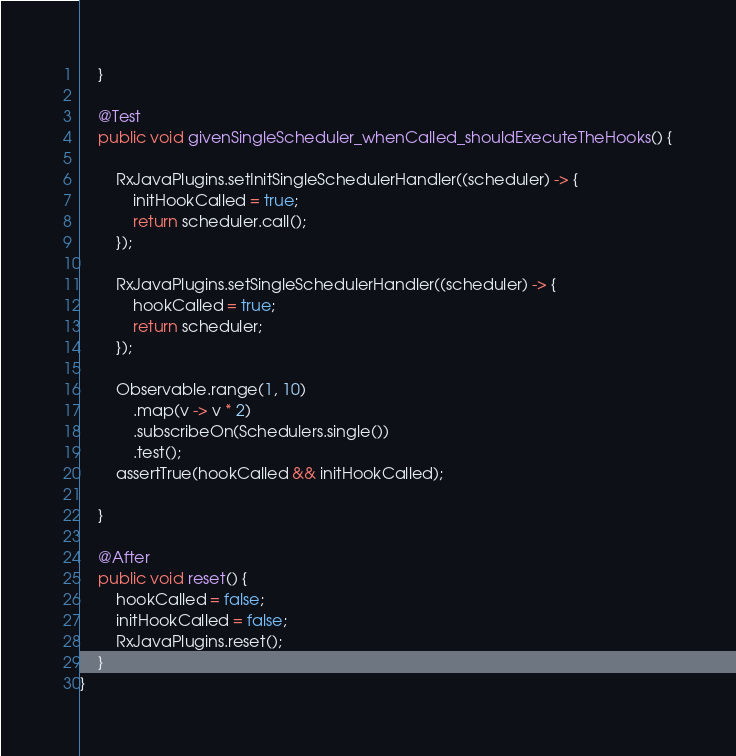<code> <loc_0><loc_0><loc_500><loc_500><_Java_>    }

    @Test
    public void givenSingleScheduler_whenCalled_shouldExecuteTheHooks() {

        RxJavaPlugins.setInitSingleSchedulerHandler((scheduler) -> {
            initHookCalled = true;
            return scheduler.call();
        });

        RxJavaPlugins.setSingleSchedulerHandler((scheduler) -> {
            hookCalled = true;
            return scheduler;
        });

        Observable.range(1, 10)
            .map(v -> v * 2)
            .subscribeOn(Schedulers.single())
            .test();
        assertTrue(hookCalled && initHookCalled);

    }
    
    @After
    public void reset() {
        hookCalled = false;
        initHookCalled = false;
        RxJavaPlugins.reset();
    }
}
</code> 